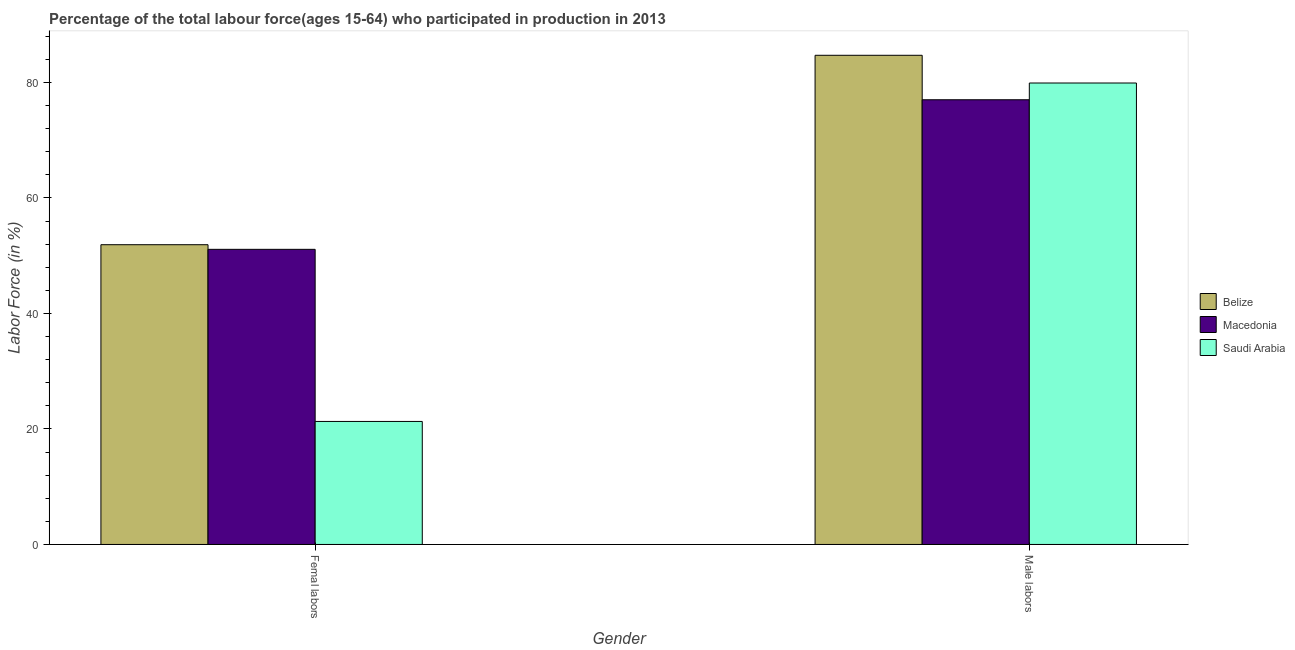How many different coloured bars are there?
Your answer should be very brief. 3. How many bars are there on the 1st tick from the right?
Your answer should be compact. 3. What is the label of the 1st group of bars from the left?
Your response must be concise. Femal labors. What is the percentage of male labour force in Belize?
Your answer should be very brief. 84.7. Across all countries, what is the maximum percentage of female labor force?
Ensure brevity in your answer.  51.9. Across all countries, what is the minimum percentage of male labour force?
Your response must be concise. 77. In which country was the percentage of male labour force maximum?
Provide a short and direct response. Belize. In which country was the percentage of male labour force minimum?
Keep it short and to the point. Macedonia. What is the total percentage of female labor force in the graph?
Your response must be concise. 124.3. What is the difference between the percentage of female labor force in Saudi Arabia and that in Belize?
Your answer should be very brief. -30.6. What is the difference between the percentage of male labour force in Belize and the percentage of female labor force in Saudi Arabia?
Your response must be concise. 63.4. What is the average percentage of female labor force per country?
Offer a very short reply. 41.43. What is the difference between the percentage of female labor force and percentage of male labour force in Saudi Arabia?
Make the answer very short. -58.6. In how many countries, is the percentage of female labor force greater than 28 %?
Make the answer very short. 2. What is the ratio of the percentage of female labor force in Belize to that in Saudi Arabia?
Offer a terse response. 2.44. Is the percentage of male labour force in Macedonia less than that in Saudi Arabia?
Your answer should be compact. Yes. In how many countries, is the percentage of male labour force greater than the average percentage of male labour force taken over all countries?
Offer a terse response. 1. What does the 1st bar from the left in Femal labors represents?
Offer a very short reply. Belize. What does the 2nd bar from the right in Femal labors represents?
Provide a succinct answer. Macedonia. What is the difference between two consecutive major ticks on the Y-axis?
Give a very brief answer. 20. Does the graph contain grids?
Ensure brevity in your answer.  No. What is the title of the graph?
Keep it short and to the point. Percentage of the total labour force(ages 15-64) who participated in production in 2013. What is the label or title of the X-axis?
Give a very brief answer. Gender. What is the Labor Force (in %) in Belize in Femal labors?
Ensure brevity in your answer.  51.9. What is the Labor Force (in %) in Macedonia in Femal labors?
Ensure brevity in your answer.  51.1. What is the Labor Force (in %) of Saudi Arabia in Femal labors?
Keep it short and to the point. 21.3. What is the Labor Force (in %) of Belize in Male labors?
Offer a very short reply. 84.7. What is the Labor Force (in %) of Macedonia in Male labors?
Your response must be concise. 77. What is the Labor Force (in %) of Saudi Arabia in Male labors?
Give a very brief answer. 79.9. Across all Gender, what is the maximum Labor Force (in %) in Belize?
Your answer should be compact. 84.7. Across all Gender, what is the maximum Labor Force (in %) in Macedonia?
Your answer should be very brief. 77. Across all Gender, what is the maximum Labor Force (in %) of Saudi Arabia?
Provide a succinct answer. 79.9. Across all Gender, what is the minimum Labor Force (in %) in Belize?
Offer a very short reply. 51.9. Across all Gender, what is the minimum Labor Force (in %) of Macedonia?
Make the answer very short. 51.1. Across all Gender, what is the minimum Labor Force (in %) of Saudi Arabia?
Provide a short and direct response. 21.3. What is the total Labor Force (in %) in Belize in the graph?
Keep it short and to the point. 136.6. What is the total Labor Force (in %) of Macedonia in the graph?
Your answer should be very brief. 128.1. What is the total Labor Force (in %) in Saudi Arabia in the graph?
Give a very brief answer. 101.2. What is the difference between the Labor Force (in %) of Belize in Femal labors and that in Male labors?
Provide a succinct answer. -32.8. What is the difference between the Labor Force (in %) in Macedonia in Femal labors and that in Male labors?
Provide a succinct answer. -25.9. What is the difference between the Labor Force (in %) in Saudi Arabia in Femal labors and that in Male labors?
Your answer should be compact. -58.6. What is the difference between the Labor Force (in %) in Belize in Femal labors and the Labor Force (in %) in Macedonia in Male labors?
Make the answer very short. -25.1. What is the difference between the Labor Force (in %) in Macedonia in Femal labors and the Labor Force (in %) in Saudi Arabia in Male labors?
Offer a very short reply. -28.8. What is the average Labor Force (in %) in Belize per Gender?
Provide a succinct answer. 68.3. What is the average Labor Force (in %) in Macedonia per Gender?
Give a very brief answer. 64.05. What is the average Labor Force (in %) in Saudi Arabia per Gender?
Provide a succinct answer. 50.6. What is the difference between the Labor Force (in %) of Belize and Labor Force (in %) of Macedonia in Femal labors?
Offer a very short reply. 0.8. What is the difference between the Labor Force (in %) in Belize and Labor Force (in %) in Saudi Arabia in Femal labors?
Your answer should be compact. 30.6. What is the difference between the Labor Force (in %) in Macedonia and Labor Force (in %) in Saudi Arabia in Femal labors?
Offer a very short reply. 29.8. What is the difference between the Labor Force (in %) in Belize and Labor Force (in %) in Macedonia in Male labors?
Offer a very short reply. 7.7. What is the difference between the Labor Force (in %) of Belize and Labor Force (in %) of Saudi Arabia in Male labors?
Your answer should be compact. 4.8. What is the ratio of the Labor Force (in %) of Belize in Femal labors to that in Male labors?
Offer a very short reply. 0.61. What is the ratio of the Labor Force (in %) of Macedonia in Femal labors to that in Male labors?
Your response must be concise. 0.66. What is the ratio of the Labor Force (in %) in Saudi Arabia in Femal labors to that in Male labors?
Ensure brevity in your answer.  0.27. What is the difference between the highest and the second highest Labor Force (in %) of Belize?
Your answer should be very brief. 32.8. What is the difference between the highest and the second highest Labor Force (in %) of Macedonia?
Provide a succinct answer. 25.9. What is the difference between the highest and the second highest Labor Force (in %) of Saudi Arabia?
Keep it short and to the point. 58.6. What is the difference between the highest and the lowest Labor Force (in %) of Belize?
Provide a short and direct response. 32.8. What is the difference between the highest and the lowest Labor Force (in %) in Macedonia?
Provide a succinct answer. 25.9. What is the difference between the highest and the lowest Labor Force (in %) in Saudi Arabia?
Your response must be concise. 58.6. 